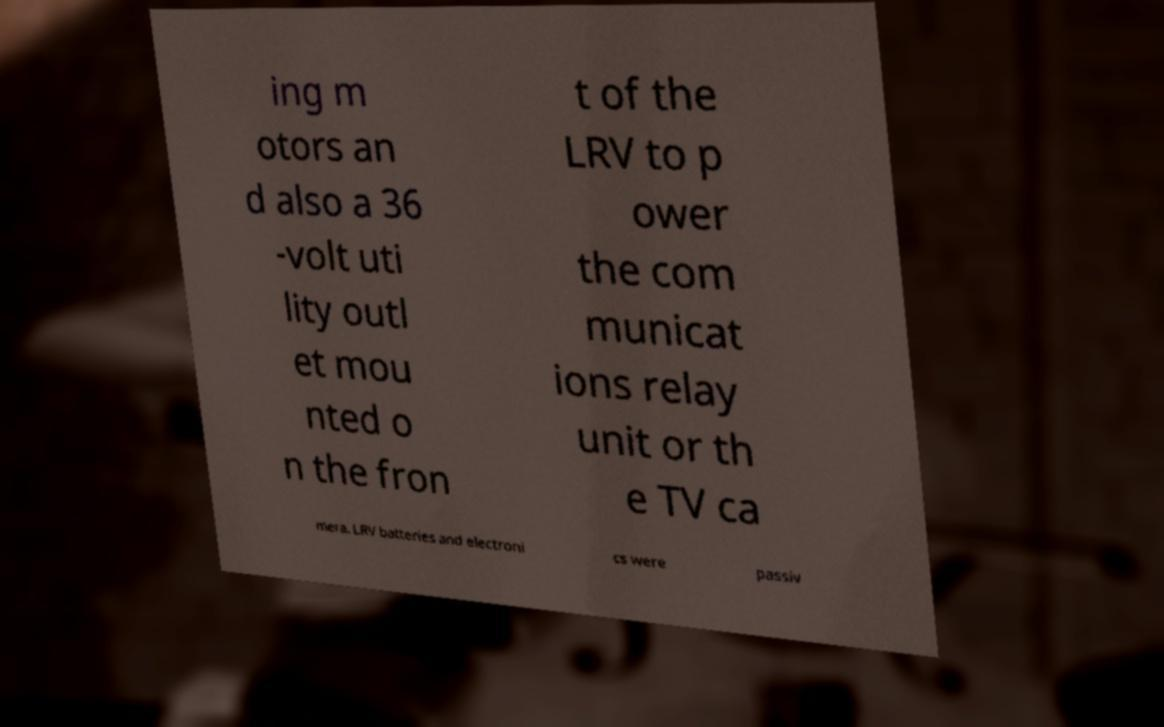What messages or text are displayed in this image? I need them in a readable, typed format. ing m otors an d also a 36 -volt uti lity outl et mou nted o n the fron t of the LRV to p ower the com municat ions relay unit or th e TV ca mera. LRV batteries and electroni cs were passiv 